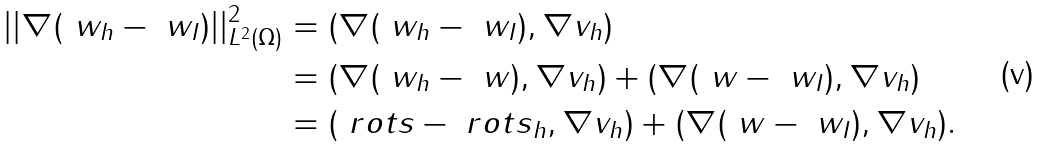Convert formula to latex. <formula><loc_0><loc_0><loc_500><loc_500>| | \nabla ( \ w _ { h } - \ w _ { I } ) | | _ { L ^ { 2 } ( \Omega ) } ^ { 2 } & = ( \nabla ( \ w _ { h } - \ w _ { I } ) , \nabla v _ { h } ) \\ & = ( \nabla ( \ w _ { h } - \ w ) , \nabla v _ { h } ) + ( \nabla ( \ w - \ w _ { I } ) , \nabla v _ { h } ) \\ & = ( \ r o t s - \ r o t s _ { h } , \nabla v _ { h } ) + ( \nabla ( \ w - \ w _ { I } ) , \nabla v _ { h } ) .</formula> 